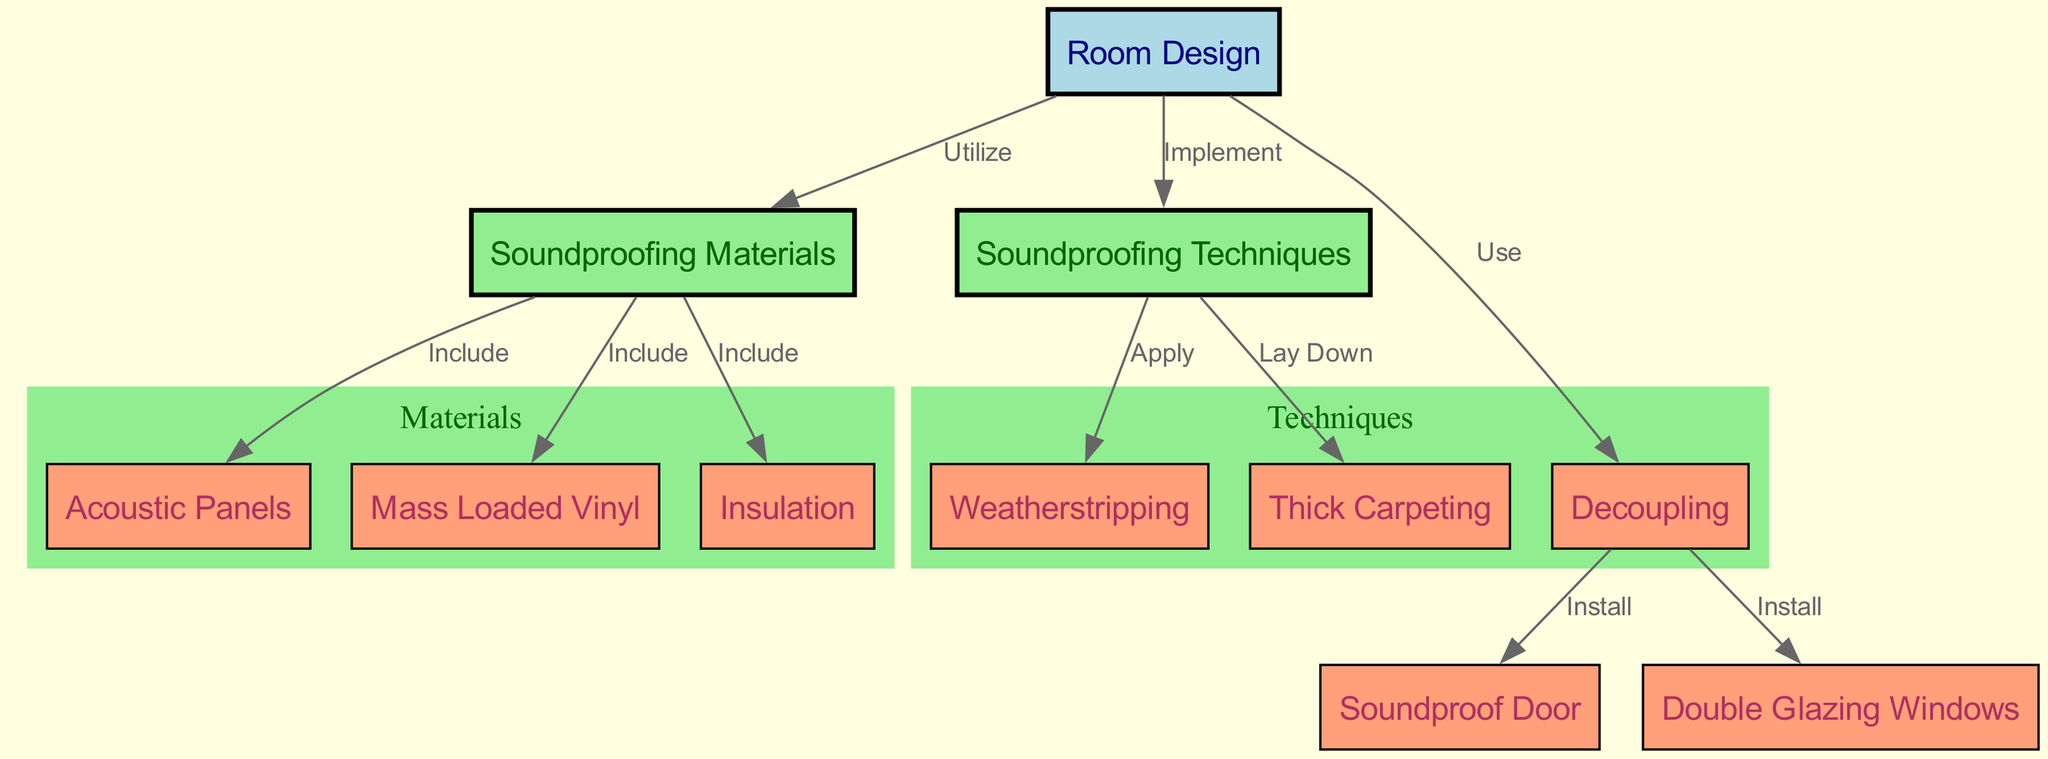What's the primary focus of the diagram? The diagram primarily focuses on soundproofing, illustrating various materials and techniques used to minimize external noise interference. The central theme connects room design with specific soundproofing elements.
Answer: Soundproofing How many soundproofing materials are included in the diagram? The diagram includes three soundproofing materials: Acoustic Panels, Mass Loaded Vinyl, and Insulation, as depicted in the cluster under Materials.
Answer: Three What technique is associated with 'weatherstripping'? The diagram illustrates that 'weatherstripping' is applied as a technique under the Techniques section, indicating its role in soundproofing.
Answer: Apply Which node represents an entry point for sound in a soundproofing setup? The node labeled 'Soundproof Door' represents an entry point for sound, showing that it needs to be installed as part of decoupling techniques to reduce noise.
Answer: Soundproof Door What are the two key connections made from 'Room Design'? The diagram shows two key connections from 'Room Design' to both 'Materials' and 'Techniques', indicating that these are both crucial components for creating effective soundproofing.
Answer: Materials and Techniques How many techniques are listed in the 'Techniques' category? There are three techniques listed under the Techniques category: Weatherstripping, Decoupling, and Thick Carpeting, as confirmed by the nodes in that section of the diagram.
Answer: Three What installation is directly linked to the 'Decoupling' method? The 'Decoupling' method is directly linked to the installation of both 'Soundproof Door' and 'Double Glazing Windows', indicating these are part of the decoupling approach to soundproofing.
Answer: Soundproof Door and Double Glazing Which soundproofing material is primarily focused on mass damping? The material 'Mass Loaded Vinyl' is primarily focused on mass damping, as indicated in its connection to the 'Materials' node.
Answer: Mass Loaded Vinyl What does 'Thick Carpeting' fall under in the diagram? 'Thick Carpeting' falls under the 'Techniques' category in the diagram, showing its role as a practical method for soundproofing.
Answer: Techniques 